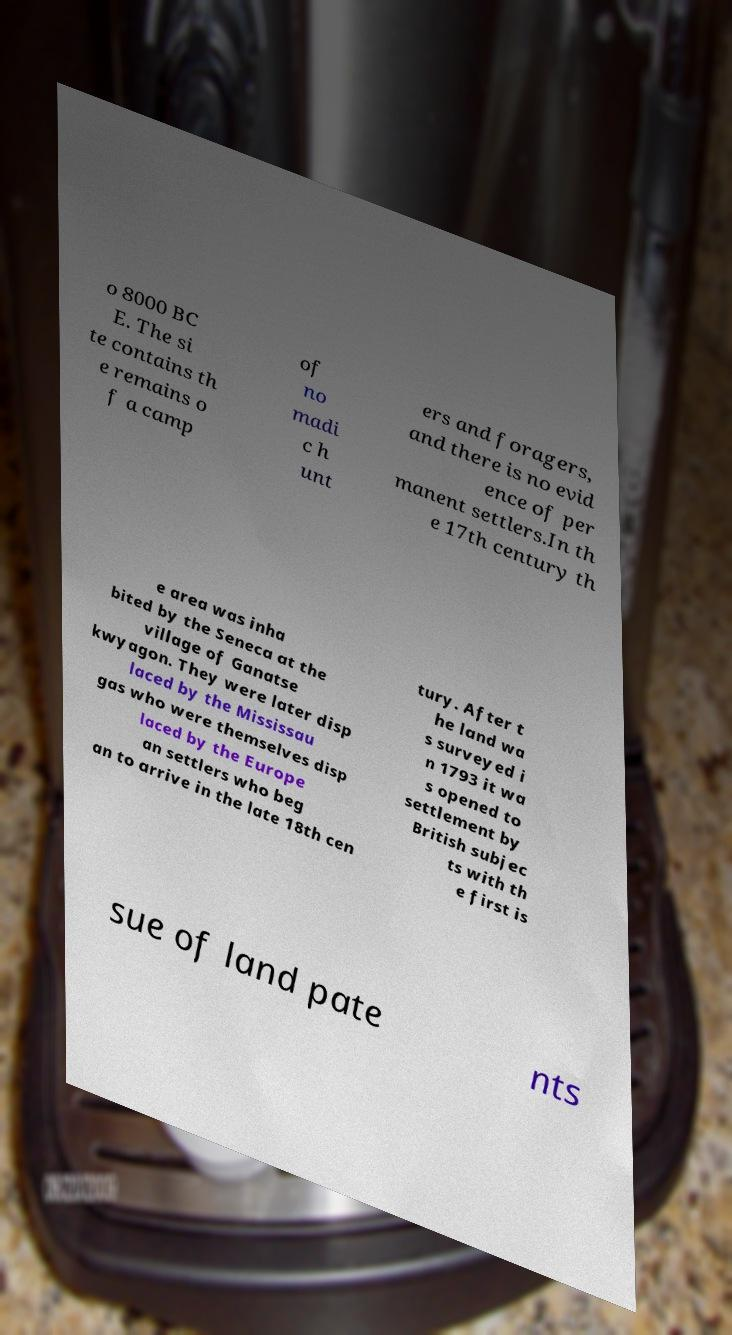Please identify and transcribe the text found in this image. o 8000 BC E. The si te contains th e remains o f a camp of no madi c h unt ers and foragers, and there is no evid ence of per manent settlers.In th e 17th century th e area was inha bited by the Seneca at the village of Ganatse kwyagon. They were later disp laced by the Mississau gas who were themselves disp laced by the Europe an settlers who beg an to arrive in the late 18th cen tury. After t he land wa s surveyed i n 1793 it wa s opened to settlement by British subjec ts with th e first is sue of land pate nts 